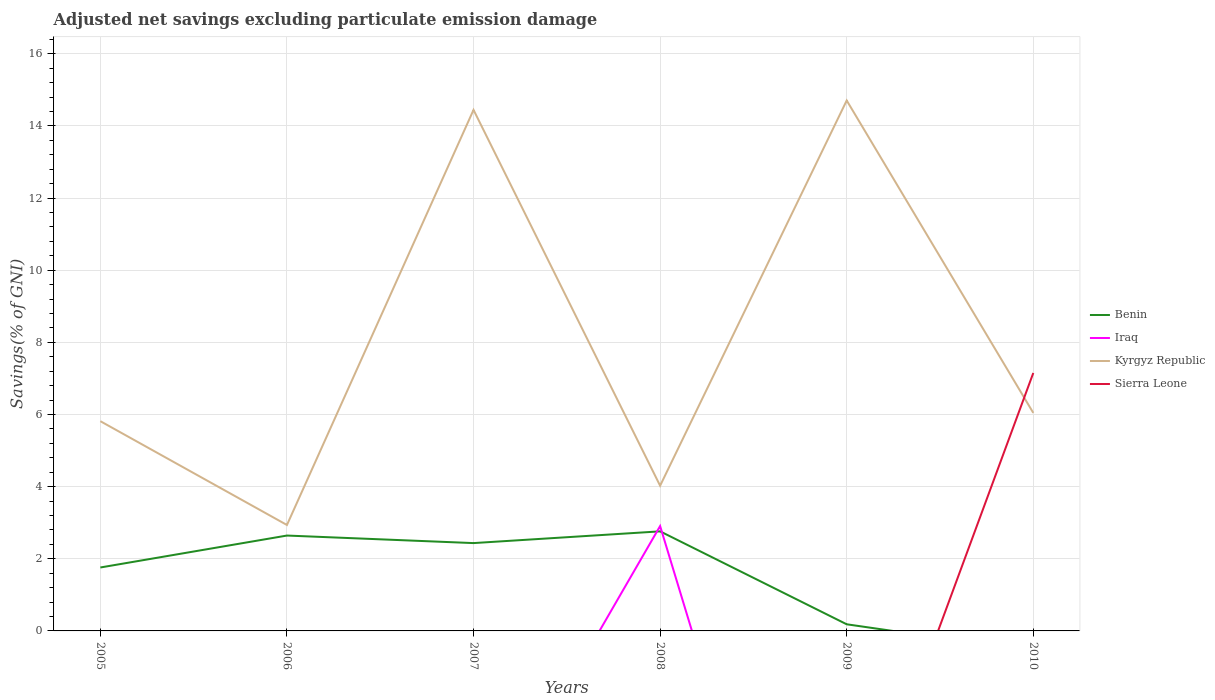Does the line corresponding to Iraq intersect with the line corresponding to Benin?
Offer a very short reply. Yes. Across all years, what is the maximum adjusted net savings in Benin?
Your answer should be compact. 0. What is the total adjusted net savings in Kyrgyz Republic in the graph?
Offer a very short reply. -11.77. What is the difference between the highest and the second highest adjusted net savings in Sierra Leone?
Provide a short and direct response. 7.15. What is the difference between the highest and the lowest adjusted net savings in Sierra Leone?
Provide a succinct answer. 1. Does the graph contain any zero values?
Offer a terse response. Yes. How many legend labels are there?
Make the answer very short. 4. What is the title of the graph?
Ensure brevity in your answer.  Adjusted net savings excluding particulate emission damage. Does "Ukraine" appear as one of the legend labels in the graph?
Your answer should be very brief. No. What is the label or title of the Y-axis?
Give a very brief answer. Savings(% of GNI). What is the Savings(% of GNI) in Benin in 2005?
Your answer should be very brief. 1.76. What is the Savings(% of GNI) in Iraq in 2005?
Ensure brevity in your answer.  0. What is the Savings(% of GNI) in Kyrgyz Republic in 2005?
Ensure brevity in your answer.  5.82. What is the Savings(% of GNI) of Sierra Leone in 2005?
Keep it short and to the point. 0. What is the Savings(% of GNI) of Benin in 2006?
Your answer should be compact. 2.64. What is the Savings(% of GNI) of Kyrgyz Republic in 2006?
Your response must be concise. 2.94. What is the Savings(% of GNI) of Sierra Leone in 2006?
Your answer should be compact. 0. What is the Savings(% of GNI) in Benin in 2007?
Make the answer very short. 2.44. What is the Savings(% of GNI) of Iraq in 2007?
Give a very brief answer. 0. What is the Savings(% of GNI) in Kyrgyz Republic in 2007?
Your answer should be very brief. 14.45. What is the Savings(% of GNI) of Benin in 2008?
Provide a short and direct response. 2.76. What is the Savings(% of GNI) in Iraq in 2008?
Provide a succinct answer. 2.91. What is the Savings(% of GNI) in Kyrgyz Republic in 2008?
Make the answer very short. 4.03. What is the Savings(% of GNI) in Sierra Leone in 2008?
Your answer should be very brief. 0. What is the Savings(% of GNI) in Benin in 2009?
Ensure brevity in your answer.  0.18. What is the Savings(% of GNI) of Iraq in 2009?
Your response must be concise. 0. What is the Savings(% of GNI) of Kyrgyz Republic in 2009?
Keep it short and to the point. 14.71. What is the Savings(% of GNI) in Kyrgyz Republic in 2010?
Provide a succinct answer. 6.05. What is the Savings(% of GNI) of Sierra Leone in 2010?
Offer a very short reply. 7.15. Across all years, what is the maximum Savings(% of GNI) in Benin?
Make the answer very short. 2.76. Across all years, what is the maximum Savings(% of GNI) of Iraq?
Your response must be concise. 2.91. Across all years, what is the maximum Savings(% of GNI) in Kyrgyz Republic?
Ensure brevity in your answer.  14.71. Across all years, what is the maximum Savings(% of GNI) in Sierra Leone?
Provide a short and direct response. 7.15. Across all years, what is the minimum Savings(% of GNI) in Benin?
Make the answer very short. 0. Across all years, what is the minimum Savings(% of GNI) in Kyrgyz Republic?
Ensure brevity in your answer.  2.94. What is the total Savings(% of GNI) of Benin in the graph?
Provide a succinct answer. 9.78. What is the total Savings(% of GNI) in Iraq in the graph?
Make the answer very short. 2.91. What is the total Savings(% of GNI) in Kyrgyz Republic in the graph?
Provide a short and direct response. 47.98. What is the total Savings(% of GNI) in Sierra Leone in the graph?
Ensure brevity in your answer.  7.15. What is the difference between the Savings(% of GNI) in Benin in 2005 and that in 2006?
Provide a succinct answer. -0.89. What is the difference between the Savings(% of GNI) in Kyrgyz Republic in 2005 and that in 2006?
Keep it short and to the point. 2.88. What is the difference between the Savings(% of GNI) in Benin in 2005 and that in 2007?
Make the answer very short. -0.68. What is the difference between the Savings(% of GNI) in Kyrgyz Republic in 2005 and that in 2007?
Make the answer very short. -8.63. What is the difference between the Savings(% of GNI) in Benin in 2005 and that in 2008?
Give a very brief answer. -1. What is the difference between the Savings(% of GNI) of Kyrgyz Republic in 2005 and that in 2008?
Your answer should be very brief. 1.79. What is the difference between the Savings(% of GNI) of Benin in 2005 and that in 2009?
Offer a very short reply. 1.57. What is the difference between the Savings(% of GNI) of Kyrgyz Republic in 2005 and that in 2009?
Keep it short and to the point. -8.89. What is the difference between the Savings(% of GNI) in Kyrgyz Republic in 2005 and that in 2010?
Your answer should be compact. -0.23. What is the difference between the Savings(% of GNI) of Benin in 2006 and that in 2007?
Ensure brevity in your answer.  0.21. What is the difference between the Savings(% of GNI) in Kyrgyz Republic in 2006 and that in 2007?
Offer a very short reply. -11.51. What is the difference between the Savings(% of GNI) of Benin in 2006 and that in 2008?
Give a very brief answer. -0.12. What is the difference between the Savings(% of GNI) in Kyrgyz Republic in 2006 and that in 2008?
Offer a very short reply. -1.09. What is the difference between the Savings(% of GNI) of Benin in 2006 and that in 2009?
Keep it short and to the point. 2.46. What is the difference between the Savings(% of GNI) in Kyrgyz Republic in 2006 and that in 2009?
Your answer should be very brief. -11.77. What is the difference between the Savings(% of GNI) of Kyrgyz Republic in 2006 and that in 2010?
Offer a very short reply. -3.11. What is the difference between the Savings(% of GNI) of Benin in 2007 and that in 2008?
Offer a terse response. -0.33. What is the difference between the Savings(% of GNI) of Kyrgyz Republic in 2007 and that in 2008?
Provide a short and direct response. 10.42. What is the difference between the Savings(% of GNI) in Benin in 2007 and that in 2009?
Provide a short and direct response. 2.25. What is the difference between the Savings(% of GNI) in Kyrgyz Republic in 2007 and that in 2009?
Keep it short and to the point. -0.26. What is the difference between the Savings(% of GNI) in Kyrgyz Republic in 2007 and that in 2010?
Ensure brevity in your answer.  8.4. What is the difference between the Savings(% of GNI) in Benin in 2008 and that in 2009?
Keep it short and to the point. 2.58. What is the difference between the Savings(% of GNI) of Kyrgyz Republic in 2008 and that in 2009?
Your answer should be very brief. -10.68. What is the difference between the Savings(% of GNI) in Kyrgyz Republic in 2008 and that in 2010?
Keep it short and to the point. -2.02. What is the difference between the Savings(% of GNI) of Kyrgyz Republic in 2009 and that in 2010?
Your response must be concise. 8.66. What is the difference between the Savings(% of GNI) in Benin in 2005 and the Savings(% of GNI) in Kyrgyz Republic in 2006?
Provide a succinct answer. -1.18. What is the difference between the Savings(% of GNI) in Benin in 2005 and the Savings(% of GNI) in Kyrgyz Republic in 2007?
Offer a terse response. -12.69. What is the difference between the Savings(% of GNI) in Benin in 2005 and the Savings(% of GNI) in Iraq in 2008?
Make the answer very short. -1.15. What is the difference between the Savings(% of GNI) in Benin in 2005 and the Savings(% of GNI) in Kyrgyz Republic in 2008?
Give a very brief answer. -2.27. What is the difference between the Savings(% of GNI) in Benin in 2005 and the Savings(% of GNI) in Kyrgyz Republic in 2009?
Offer a very short reply. -12.95. What is the difference between the Savings(% of GNI) of Benin in 2005 and the Savings(% of GNI) of Kyrgyz Republic in 2010?
Offer a terse response. -4.29. What is the difference between the Savings(% of GNI) of Benin in 2005 and the Savings(% of GNI) of Sierra Leone in 2010?
Ensure brevity in your answer.  -5.39. What is the difference between the Savings(% of GNI) of Kyrgyz Republic in 2005 and the Savings(% of GNI) of Sierra Leone in 2010?
Your answer should be very brief. -1.34. What is the difference between the Savings(% of GNI) in Benin in 2006 and the Savings(% of GNI) in Kyrgyz Republic in 2007?
Your response must be concise. -11.8. What is the difference between the Savings(% of GNI) of Benin in 2006 and the Savings(% of GNI) of Iraq in 2008?
Provide a succinct answer. -0.26. What is the difference between the Savings(% of GNI) in Benin in 2006 and the Savings(% of GNI) in Kyrgyz Republic in 2008?
Your response must be concise. -1.38. What is the difference between the Savings(% of GNI) in Benin in 2006 and the Savings(% of GNI) in Kyrgyz Republic in 2009?
Provide a short and direct response. -12.06. What is the difference between the Savings(% of GNI) in Benin in 2006 and the Savings(% of GNI) in Kyrgyz Republic in 2010?
Provide a short and direct response. -3.4. What is the difference between the Savings(% of GNI) of Benin in 2006 and the Savings(% of GNI) of Sierra Leone in 2010?
Your answer should be compact. -4.51. What is the difference between the Savings(% of GNI) in Kyrgyz Republic in 2006 and the Savings(% of GNI) in Sierra Leone in 2010?
Provide a succinct answer. -4.21. What is the difference between the Savings(% of GNI) in Benin in 2007 and the Savings(% of GNI) in Iraq in 2008?
Offer a terse response. -0.47. What is the difference between the Savings(% of GNI) in Benin in 2007 and the Savings(% of GNI) in Kyrgyz Republic in 2008?
Keep it short and to the point. -1.59. What is the difference between the Savings(% of GNI) in Benin in 2007 and the Savings(% of GNI) in Kyrgyz Republic in 2009?
Your answer should be compact. -12.27. What is the difference between the Savings(% of GNI) in Benin in 2007 and the Savings(% of GNI) in Kyrgyz Republic in 2010?
Provide a short and direct response. -3.61. What is the difference between the Savings(% of GNI) of Benin in 2007 and the Savings(% of GNI) of Sierra Leone in 2010?
Your response must be concise. -4.72. What is the difference between the Savings(% of GNI) of Kyrgyz Republic in 2007 and the Savings(% of GNI) of Sierra Leone in 2010?
Provide a short and direct response. 7.29. What is the difference between the Savings(% of GNI) in Benin in 2008 and the Savings(% of GNI) in Kyrgyz Republic in 2009?
Give a very brief answer. -11.95. What is the difference between the Savings(% of GNI) of Iraq in 2008 and the Savings(% of GNI) of Kyrgyz Republic in 2009?
Make the answer very short. -11.8. What is the difference between the Savings(% of GNI) in Benin in 2008 and the Savings(% of GNI) in Kyrgyz Republic in 2010?
Provide a succinct answer. -3.28. What is the difference between the Savings(% of GNI) of Benin in 2008 and the Savings(% of GNI) of Sierra Leone in 2010?
Your answer should be compact. -4.39. What is the difference between the Savings(% of GNI) of Iraq in 2008 and the Savings(% of GNI) of Kyrgyz Republic in 2010?
Your answer should be compact. -3.14. What is the difference between the Savings(% of GNI) of Iraq in 2008 and the Savings(% of GNI) of Sierra Leone in 2010?
Your answer should be very brief. -4.24. What is the difference between the Savings(% of GNI) of Kyrgyz Republic in 2008 and the Savings(% of GNI) of Sierra Leone in 2010?
Make the answer very short. -3.13. What is the difference between the Savings(% of GNI) in Benin in 2009 and the Savings(% of GNI) in Kyrgyz Republic in 2010?
Offer a terse response. -5.86. What is the difference between the Savings(% of GNI) of Benin in 2009 and the Savings(% of GNI) of Sierra Leone in 2010?
Keep it short and to the point. -6.97. What is the difference between the Savings(% of GNI) of Kyrgyz Republic in 2009 and the Savings(% of GNI) of Sierra Leone in 2010?
Offer a terse response. 7.55. What is the average Savings(% of GNI) in Benin per year?
Your answer should be very brief. 1.63. What is the average Savings(% of GNI) in Iraq per year?
Provide a succinct answer. 0.48. What is the average Savings(% of GNI) in Kyrgyz Republic per year?
Your answer should be very brief. 8. What is the average Savings(% of GNI) of Sierra Leone per year?
Offer a terse response. 1.19. In the year 2005, what is the difference between the Savings(% of GNI) of Benin and Savings(% of GNI) of Kyrgyz Republic?
Your response must be concise. -4.06. In the year 2006, what is the difference between the Savings(% of GNI) in Benin and Savings(% of GNI) in Kyrgyz Republic?
Make the answer very short. -0.29. In the year 2007, what is the difference between the Savings(% of GNI) in Benin and Savings(% of GNI) in Kyrgyz Republic?
Make the answer very short. -12.01. In the year 2008, what is the difference between the Savings(% of GNI) in Benin and Savings(% of GNI) in Iraq?
Offer a very short reply. -0.15. In the year 2008, what is the difference between the Savings(% of GNI) of Benin and Savings(% of GNI) of Kyrgyz Republic?
Make the answer very short. -1.26. In the year 2008, what is the difference between the Savings(% of GNI) of Iraq and Savings(% of GNI) of Kyrgyz Republic?
Offer a very short reply. -1.12. In the year 2009, what is the difference between the Savings(% of GNI) of Benin and Savings(% of GNI) of Kyrgyz Republic?
Ensure brevity in your answer.  -14.52. In the year 2010, what is the difference between the Savings(% of GNI) in Kyrgyz Republic and Savings(% of GNI) in Sierra Leone?
Make the answer very short. -1.11. What is the ratio of the Savings(% of GNI) of Benin in 2005 to that in 2006?
Your answer should be compact. 0.67. What is the ratio of the Savings(% of GNI) in Kyrgyz Republic in 2005 to that in 2006?
Offer a terse response. 1.98. What is the ratio of the Savings(% of GNI) in Benin in 2005 to that in 2007?
Give a very brief answer. 0.72. What is the ratio of the Savings(% of GNI) of Kyrgyz Republic in 2005 to that in 2007?
Your answer should be very brief. 0.4. What is the ratio of the Savings(% of GNI) of Benin in 2005 to that in 2008?
Offer a terse response. 0.64. What is the ratio of the Savings(% of GNI) of Kyrgyz Republic in 2005 to that in 2008?
Provide a succinct answer. 1.44. What is the ratio of the Savings(% of GNI) of Benin in 2005 to that in 2009?
Ensure brevity in your answer.  9.57. What is the ratio of the Savings(% of GNI) in Kyrgyz Republic in 2005 to that in 2009?
Your answer should be compact. 0.4. What is the ratio of the Savings(% of GNI) of Kyrgyz Republic in 2005 to that in 2010?
Your answer should be compact. 0.96. What is the ratio of the Savings(% of GNI) in Benin in 2006 to that in 2007?
Your response must be concise. 1.09. What is the ratio of the Savings(% of GNI) in Kyrgyz Republic in 2006 to that in 2007?
Keep it short and to the point. 0.2. What is the ratio of the Savings(% of GNI) of Benin in 2006 to that in 2008?
Your response must be concise. 0.96. What is the ratio of the Savings(% of GNI) in Kyrgyz Republic in 2006 to that in 2008?
Offer a very short reply. 0.73. What is the ratio of the Savings(% of GNI) in Benin in 2006 to that in 2009?
Provide a short and direct response. 14.38. What is the ratio of the Savings(% of GNI) of Kyrgyz Republic in 2006 to that in 2009?
Your answer should be compact. 0.2. What is the ratio of the Savings(% of GNI) of Kyrgyz Republic in 2006 to that in 2010?
Keep it short and to the point. 0.49. What is the ratio of the Savings(% of GNI) in Benin in 2007 to that in 2008?
Your response must be concise. 0.88. What is the ratio of the Savings(% of GNI) of Kyrgyz Republic in 2007 to that in 2008?
Your answer should be very brief. 3.59. What is the ratio of the Savings(% of GNI) of Benin in 2007 to that in 2009?
Provide a short and direct response. 13.25. What is the ratio of the Savings(% of GNI) in Kyrgyz Republic in 2007 to that in 2009?
Offer a terse response. 0.98. What is the ratio of the Savings(% of GNI) in Kyrgyz Republic in 2007 to that in 2010?
Provide a succinct answer. 2.39. What is the ratio of the Savings(% of GNI) of Benin in 2008 to that in 2009?
Keep it short and to the point. 15.02. What is the ratio of the Savings(% of GNI) in Kyrgyz Republic in 2008 to that in 2009?
Offer a very short reply. 0.27. What is the ratio of the Savings(% of GNI) in Kyrgyz Republic in 2008 to that in 2010?
Offer a very short reply. 0.67. What is the ratio of the Savings(% of GNI) in Kyrgyz Republic in 2009 to that in 2010?
Ensure brevity in your answer.  2.43. What is the difference between the highest and the second highest Savings(% of GNI) of Benin?
Keep it short and to the point. 0.12. What is the difference between the highest and the second highest Savings(% of GNI) in Kyrgyz Republic?
Your answer should be compact. 0.26. What is the difference between the highest and the lowest Savings(% of GNI) in Benin?
Keep it short and to the point. 2.76. What is the difference between the highest and the lowest Savings(% of GNI) in Iraq?
Provide a succinct answer. 2.91. What is the difference between the highest and the lowest Savings(% of GNI) in Kyrgyz Republic?
Your answer should be very brief. 11.77. What is the difference between the highest and the lowest Savings(% of GNI) in Sierra Leone?
Offer a very short reply. 7.15. 